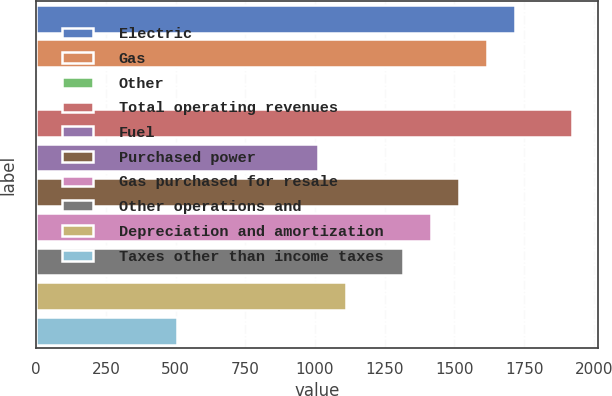Convert chart. <chart><loc_0><loc_0><loc_500><loc_500><bar_chart><fcel>Electric<fcel>Gas<fcel>Other<fcel>Total operating revenues<fcel>Fuel<fcel>Purchased power<fcel>Gas purchased for resale<fcel>Other operations and<fcel>Depreciation and amortization<fcel>Taxes other than income taxes<nl><fcel>1718<fcel>1617<fcel>1<fcel>1920<fcel>1011<fcel>1516<fcel>1415<fcel>1314<fcel>1112<fcel>506<nl></chart> 